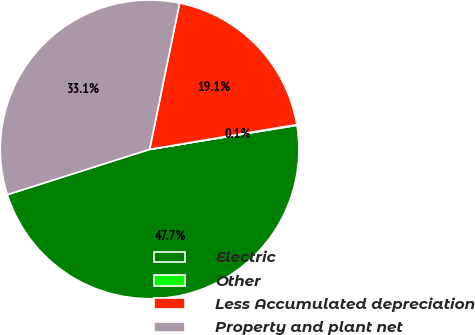Convert chart to OTSL. <chart><loc_0><loc_0><loc_500><loc_500><pie_chart><fcel>Electric<fcel>Other<fcel>Less Accumulated depreciation<fcel>Property and plant net<nl><fcel>47.68%<fcel>0.08%<fcel>19.13%<fcel>33.12%<nl></chart> 